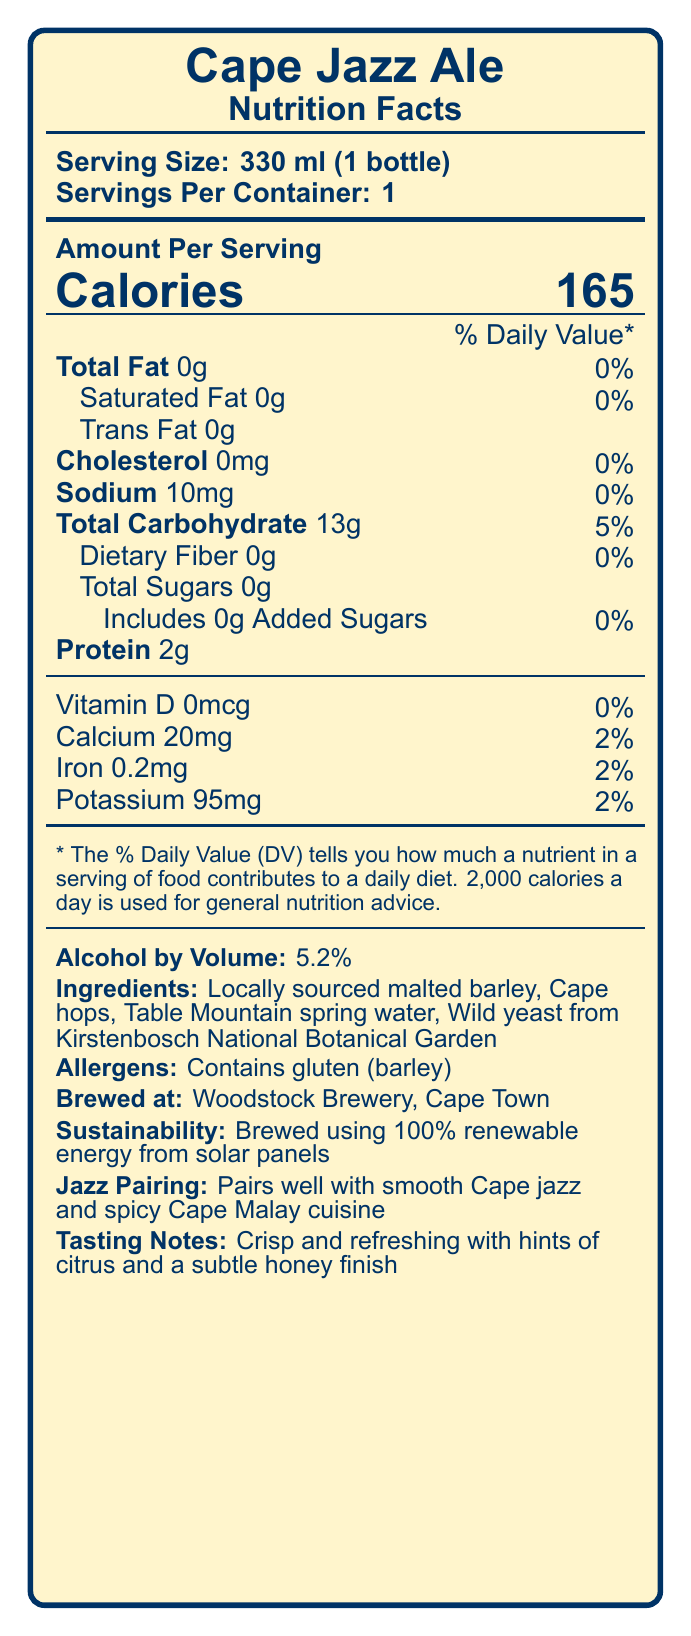what is the serving size for Cape Jazz Ale? The document specifies the serving size as 330 ml, which is equivalent to one bottle.
Answer: 330 ml (1 bottle) how many calories are in one serving of Cape Jazz Ale? Under "Amount Per Serving," the document lists the number of calories as 165.
Answer: 165 what percentage of Daily Value is the Total Fat in Cape Jazz Ale? The Total Fat is listed as 0g, and the corresponding Daily Value percentage is 0%.
Answer: 0% what is the carbohydrate content per serving? The "Total Carbohydrate" content for one serving is listed as 13g.
Answer: 13g which ingredient is responsible for the alcohol content? While the document does not directly state that yeast is responsible for the alcohol content, it is commonly known that yeast ferments sugar, producing alcohol. The ingredient list includes "wild yeast from Kirstenbosch National Botanical Garden."
Answer: Wild yeast from Kirstenbosch National Botanical Garden what is the sodium content in one serving? The document lists the sodium content as 10mg per serving.
Answer: 10mg what is the protein content in Cape Jazz Ale per serving? According to the document, the protein content per serving is 2g.
Answer: 2g how much calcium does one serving provide? The document specifies that one serving contains 20mg of calcium.
Answer: 20mg which of the following is a correct pairing suggestion for Cape Jazz Ale? 
A. Smooth Cape jazz and spicy Cape Malay cuisine 
B. Heavy metal and pizza 
C. Classical music and sushi The document states that Cape Jazz Ale pairs well with smooth Cape jazz and spicy Cape Malay cuisine.
Answer: A which brewery produces Cape Jazz Ale?
1. Cape Town Brewery 
2. Woodstock Brewery 
3. Table Mountain Brewery 
4. Kirstenbosch Brewery The document clearly mentions "Woodstock Brewery, Cape Town" as the brewing location.
Answer: 2 does Cape Jazz Ale contain any added sugars? The document lists "Added Sugars" as 0g, indicating there are no added sugars.
Answer: No is Cape Jazz Ale brewed using renewable energy? The sustainability note mentions that the beer is brewed using 100% renewable energy from solar panels.
Answer: Yes summarize the document. The summary includes key points about the beer's nutrition facts, brewing details, sustainability efforts, taste, and recommended pairings.
Answer: The document provides detailed Nutrition Facts for Cape Jazz Ale, highlighting its low fat, low sodium, and moderate calorie content. Brewed at Woodstock Brewery in Cape Town, this craft beer features locally sourced ingredients and is produced using renewable energy. It offers tasting notes of citrus and honey and pairs well with smooth Cape jazz and spicy Cape Malay cuisine. The document also includes allergen information, noting the presence of gluten. what is the iron content of Cape Jazz Ale in one serving? The document lists the iron content as 0.2mg per serving.
Answer: 0.2mg can the exact brewing process of Cape Jazz Ale be determined from the document? The document does not provide detailed information on the exact brewing process, only general information about ingredients and sustainability.
Answer: Cannot be determined 